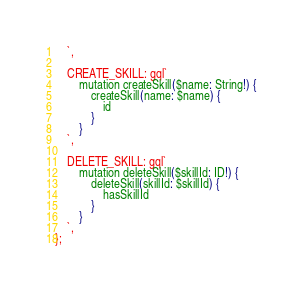<code> <loc_0><loc_0><loc_500><loc_500><_JavaScript_>    `,

    CREATE_SKILL: gql`
        mutation createSkill($name: String!) {
            createSkill(name: $name) {
                id
            }
        }
    `,

    DELETE_SKILL: gql`
        mutation deleteSkill($skillId: ID!) {
            deleteSkill(skillId: $skillId) {
                hasSkillId
            }
        }
    `,
};
</code> 